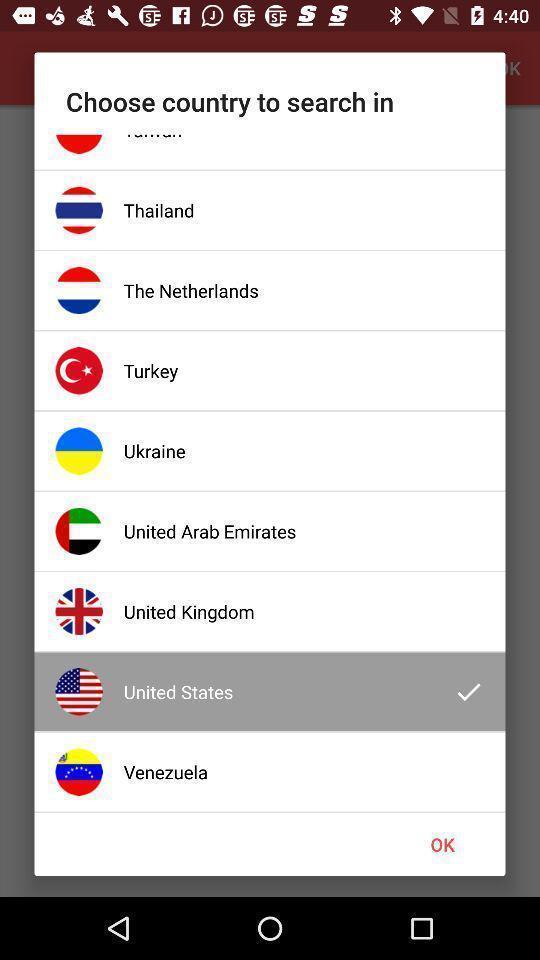Please provide a description for this image. Pop-up window is displaying different countries to be select. 